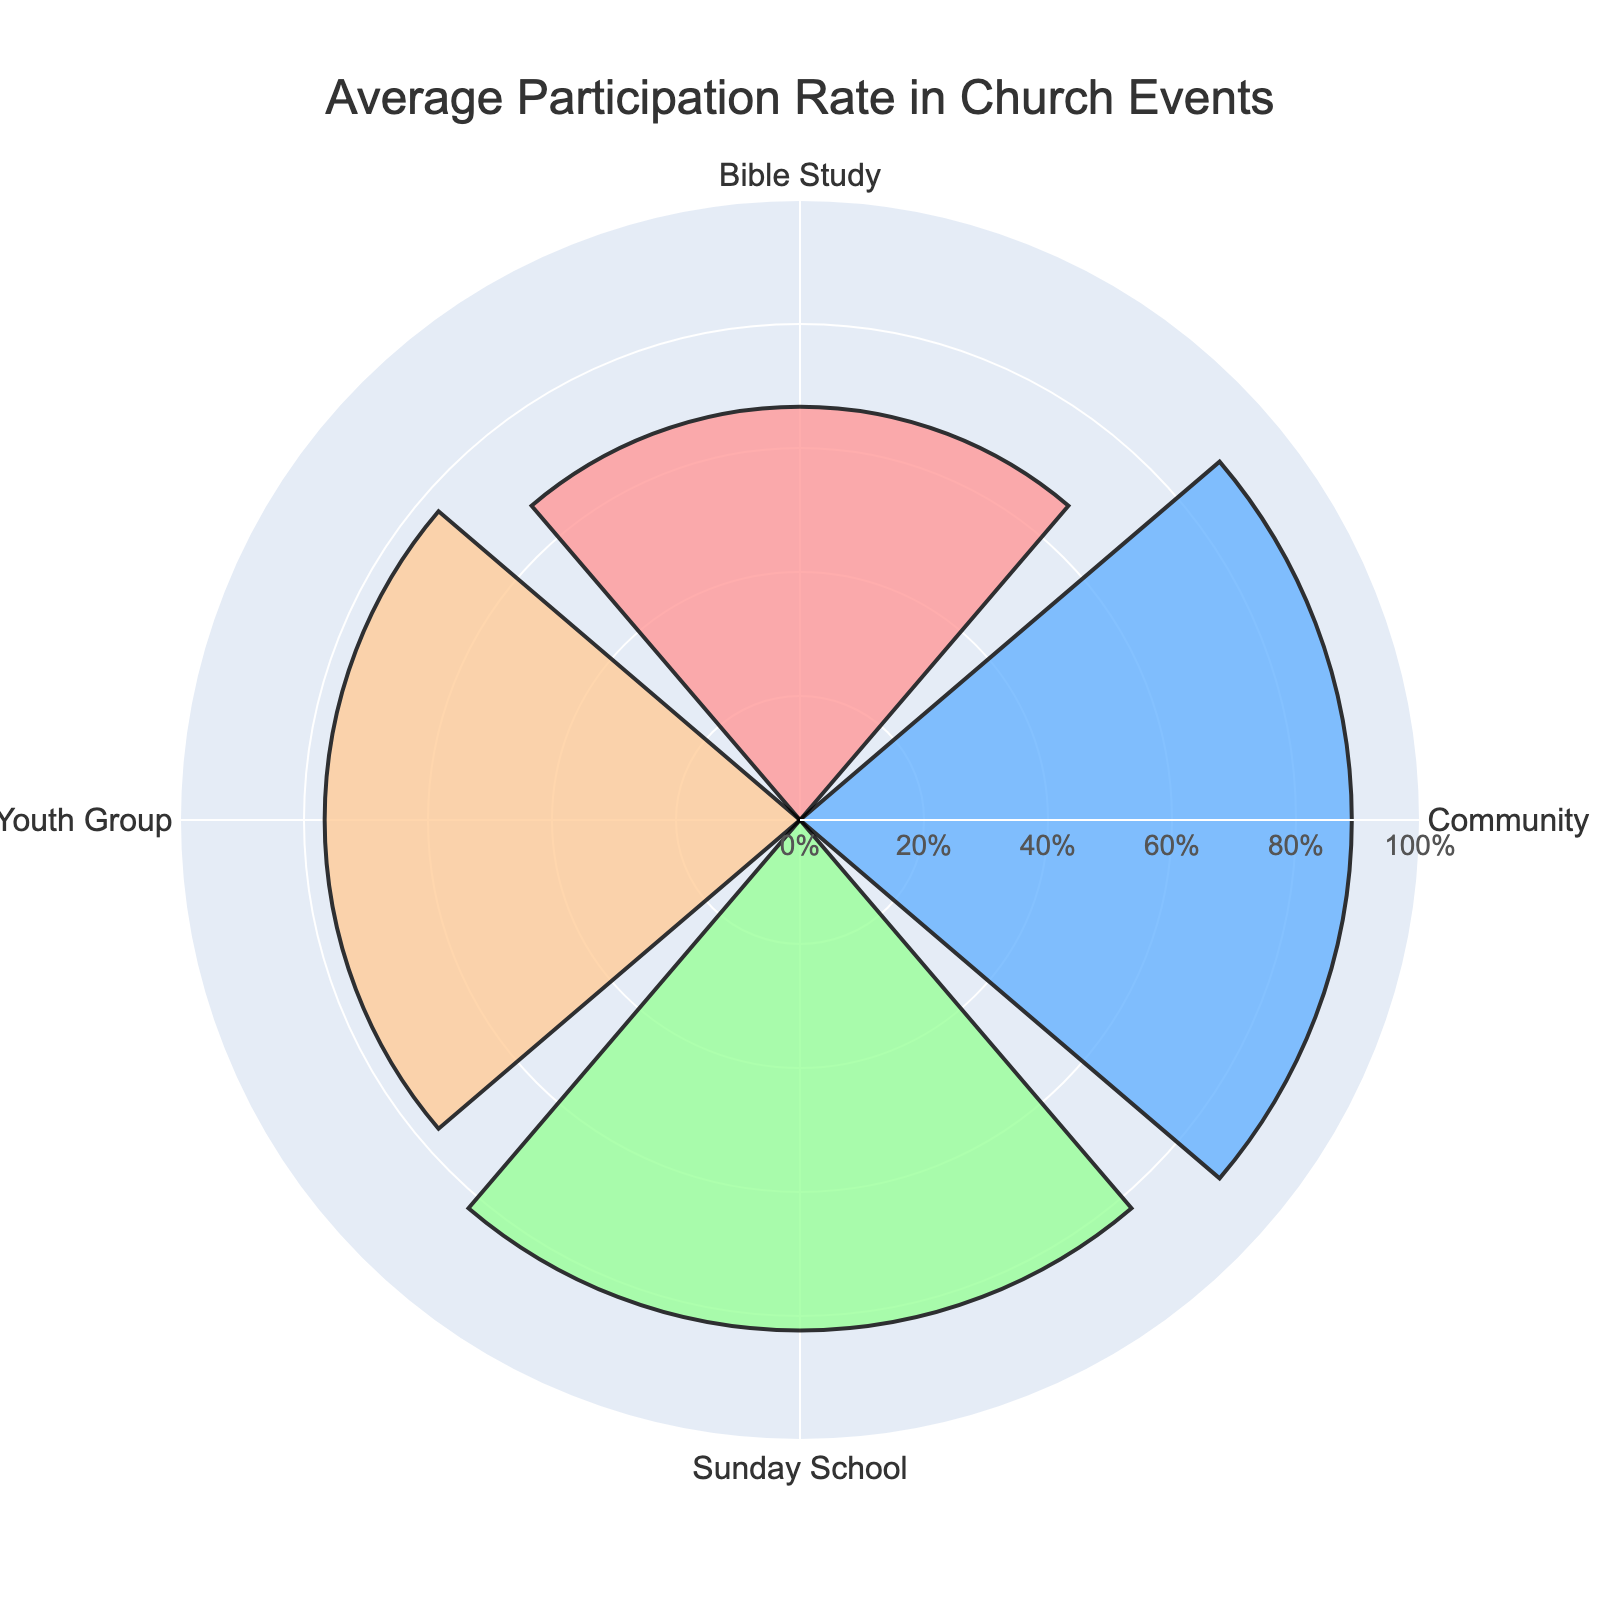What's the title of the chart? The title of the chart is always prominently displayed, often at the top of the figure.
Answer: Average Participation Rate in Church Events How many events are displayed in the chart? Visual inspection reveals four distinct groups/events shown on the chart.
Answer: Four What's the average participation rate for Sunday School? The average participation rate for each event is displayed as the length of the bar along the radial axis. Locate the bar labeled "Sunday School" and read the value.
Answer: 82% Which event has the highest average participation rate? Compare the heights of the bars for each event. The bar with the longest radius indicates the highest participation rate.
Answer: Community Dinner Which events have lower average participation rates than Sunday School? Identify the average participation rates of all events and compare them to Sunday School's rate (82%). Any event with a smaller bar falls into this category.
Answer: Youth Group, Bible Study What's the difference in average participation rates between Bible Study and Community Dinner? Subtract the average rate of Bible Study from that of Community Dinner (89% - 66.67%).
Answer: 22.33% How does Youth Group's average participation rate compare to that of Bible Study? Locate and compare the average participation rates for both events. If one bar is shorter or longer than the other, it indicates a lower or higher participation, respectively.
Answer: Higher What can you say about the range of average participation rates among the events? The bars' lengths show the participation rates ranging approximately from the shortest (Youth Group) to the longest (Community Dinner). Inspect the highest and lowest rates to determine the range.
Answer: 22.33% What's the average participation rate for events with four occurrences? Identify the events with four occurrences, Sunday School and Bible Study, and calculate their average rates (82% and 66.67%). Their average is (82 + 66.67) / 2.
Answer: 74.335% 